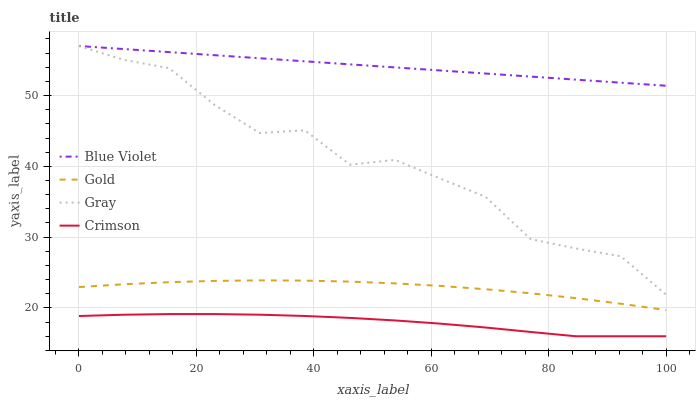Does Gray have the minimum area under the curve?
Answer yes or no. No. Does Gray have the maximum area under the curve?
Answer yes or no. No. Is Gold the smoothest?
Answer yes or no. No. Is Gold the roughest?
Answer yes or no. No. Does Gray have the lowest value?
Answer yes or no. No. Does Gold have the highest value?
Answer yes or no. No. Is Crimson less than Blue Violet?
Answer yes or no. Yes. Is Gray greater than Crimson?
Answer yes or no. Yes. Does Crimson intersect Blue Violet?
Answer yes or no. No. 